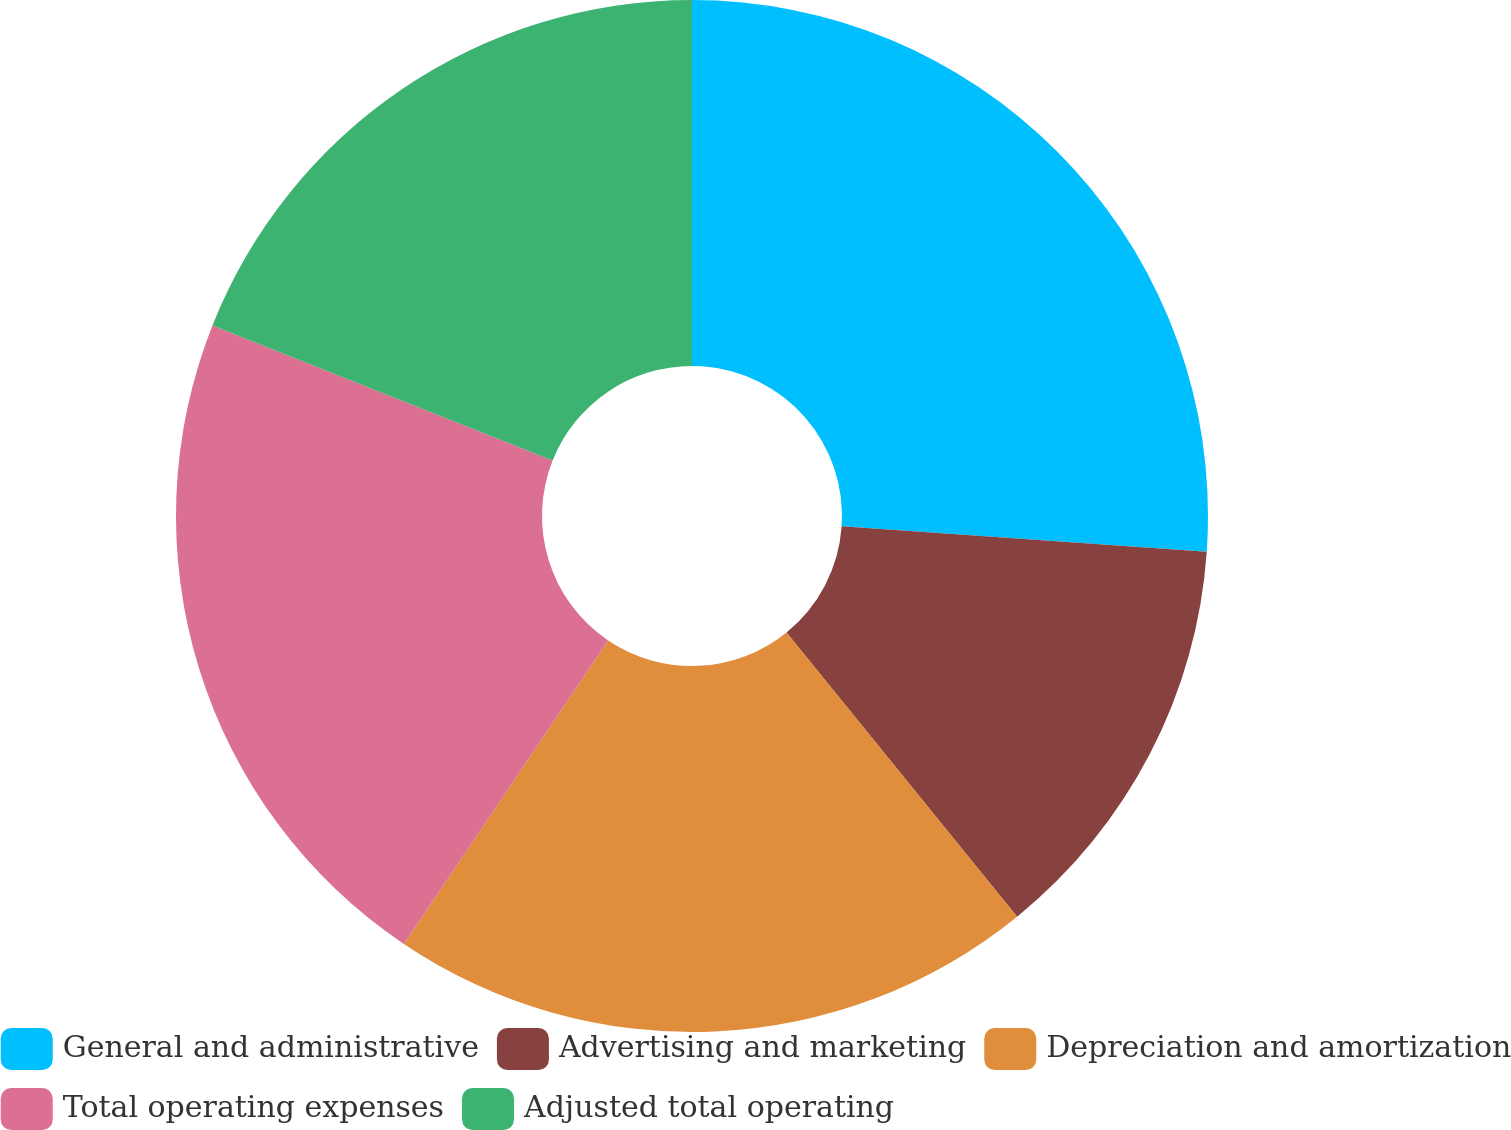<chart> <loc_0><loc_0><loc_500><loc_500><pie_chart><fcel>General and administrative<fcel>Advertising and marketing<fcel>Depreciation and amortization<fcel>Total operating expenses<fcel>Adjusted total operating<nl><fcel>26.1%<fcel>13.05%<fcel>20.28%<fcel>21.59%<fcel>18.98%<nl></chart> 